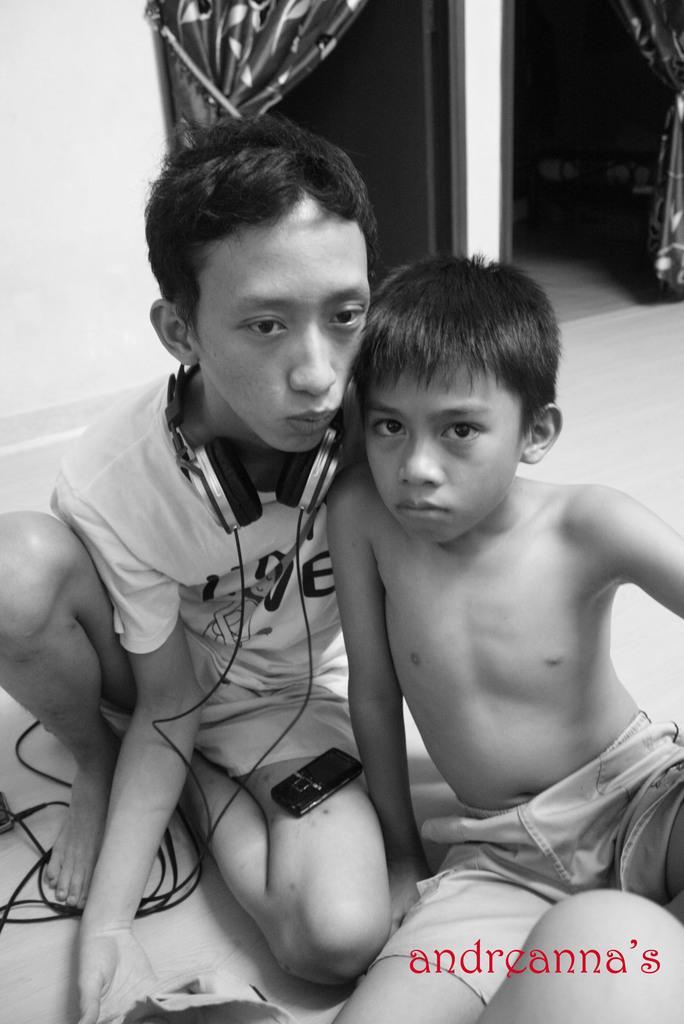Can you describe this image briefly? In this image I can see two boys are sitting on the floor. On the left side of the image I can see a headphone around the one boy's neck and on his thigh I can see a cell phone. On the bottom right side of the image I can see a watermark and in the background I can see two curtains. I can also see this image is black and white in colour. 